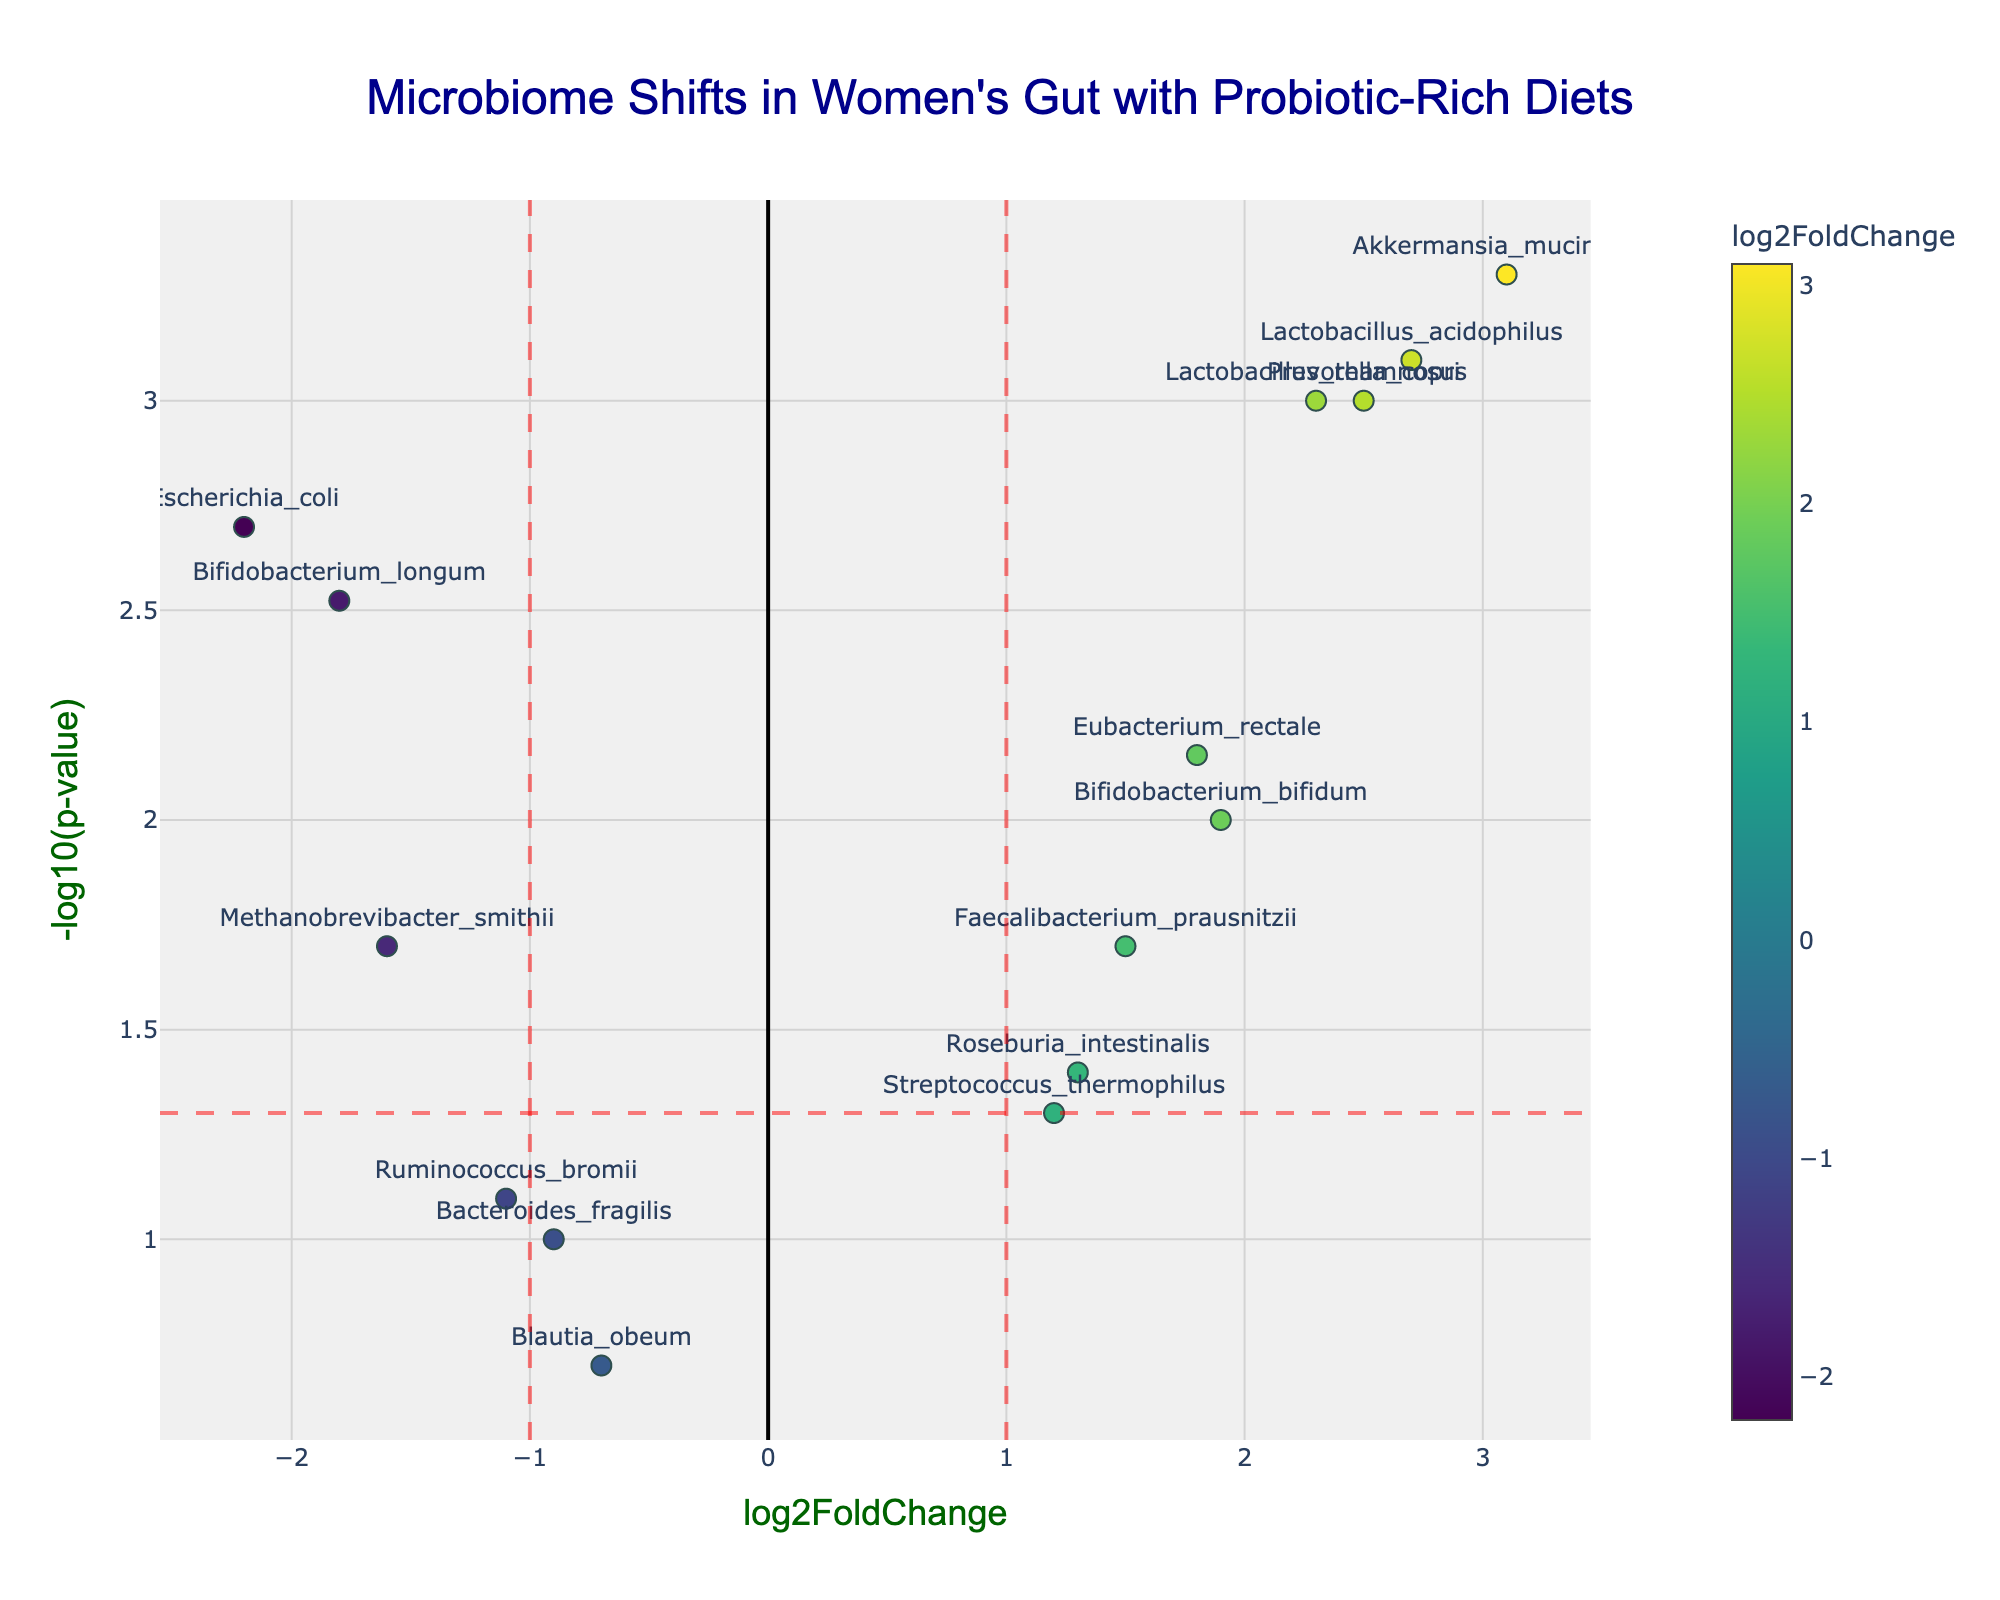What is the title of the plot? The title is typically found at the top center of the plot. In this case, it indicates the main subject being analyzed.
Answer: Microbiome Shifts in Women's Gut with Probiotic-Rich Diets How many genes have a p-value less than 0.05? To determine this, locate the horizontal line at y = -log10(0.05). Count the number of points above this line.
Answer: 10 Which gene has the highest log2FoldChange? Identify the point furthest to the right on the x-axis, corresponding to the highest log2FoldChange value.
Answer: Akkermansia_muciniphila What is the log2FoldChange and p-value of Escherichia_coli? Find the point labeled "Escherichia_coli" and read its x (log2FoldChange) and y (-log10(pvalue)) coordinates. The log2FoldChange is the x-value, and convert the y-value back to p-value using 10^(-y).
Answer: -2.2, 0.002 How many genes are highlighted in the plot? Count the number of points on the plot that are labeled with a gene name.
Answer: 15 Which genes lie within the significant thresholds, having both log2FoldChange > 1 or < -1 and p-value < 0.05? Identify the points that lie beyond the vertical lines at x = 1 and x = -1 and above the horizontal line at y = -log10(0.05).
Answer: Lactobacillus_rhamnosus, Akkermansia_muciniphila, Lactobacillus_acidophilus, Escherichia_coli, Prevotella_copri Which gene has the smallest p-value? Find the point with the highest y-coordinate since higher y-values correspond to smaller p-values.
Answer: Akkermansia_muciniphila What is the trend observed between log2FoldChange and -log10(p-value) for significantly changed genes? Examine the markers above the horizontal significance line. Check for any visual pattern or correlation between these two variables.
Answer: Positive correlation, higher log2FoldChange often corresponds to higher significance (smaller p-value) Which gene has a negative log2FoldChange but a significant p-value? Look for points that are to the left of 0 on the x-axis (indicating negative log2FoldChange) and above the horizontal line at y = -log10(0.05) (indicating significant p-value).
Answer: Bifidobacterium_longum 